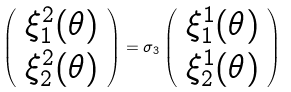<formula> <loc_0><loc_0><loc_500><loc_500>\left ( \begin{array} { c } { { \xi _ { 1 } ^ { 2 } ( \theta ) } } \\ { { \xi _ { 2 } ^ { 2 } ( \theta ) } } \end{array} \right ) = \sigma _ { 3 } \left ( \begin{array} { c } { { \xi _ { 1 } ^ { 1 } ( \theta ) } } \\ { { \xi _ { 2 } ^ { 1 } ( \theta ) } } \end{array} \right )</formula> 